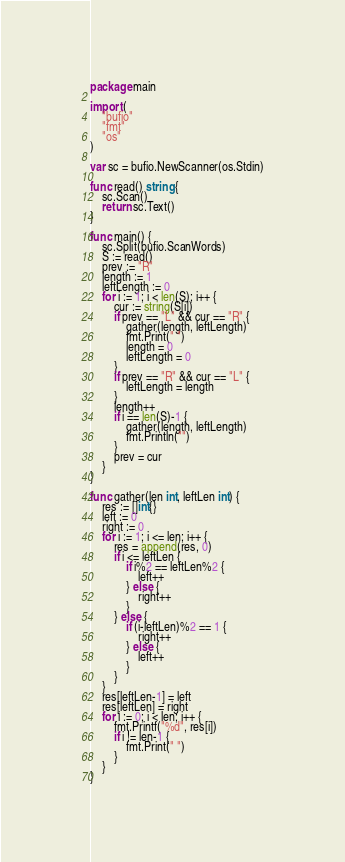Convert code to text. <code><loc_0><loc_0><loc_500><loc_500><_Go_>package main

import (
	"bufio"
	"fmt"
	"os"
)

var sc = bufio.NewScanner(os.Stdin)

func read() string {
	sc.Scan()
	return sc.Text()
}

func main() {
	sc.Split(bufio.ScanWords)
	S := read()
	prev := "R"
	length := 1
	leftLength := 0
	for i := 1; i < len(S); i++ {
		cur := string(S[i])
		if prev == "L" && cur == "R" {
			gather(length, leftLength)
			fmt.Print(" ")
			length = 0
			leftLength = 0
		}
		if prev == "R" && cur == "L" {
			leftLength = length
		}
		length++
		if i == len(S)-1 {
			gather(length, leftLength)
			fmt.Println("")
		}
		prev = cur
	}
}

func gather(len int, leftLen int) {
	res := []int{}
	left := 0
	right := 0
	for i := 1; i <= len; i++ {
		res = append(res, 0)
		if i <= leftLen {
			if i%2 == leftLen%2 {
				left++
			} else {
				right++
			}
		} else {
			if (i-leftLen)%2 == 1 {
				right++
			} else {
				left++
			}
		}
	}
	res[leftLen-1] = left
	res[leftLen] = right
	for i := 0; i < len; i++ {
		fmt.Printf("%d", res[i])
		if i != len-1 {
			fmt.Print(" ")
		}
	}
}
</code> 